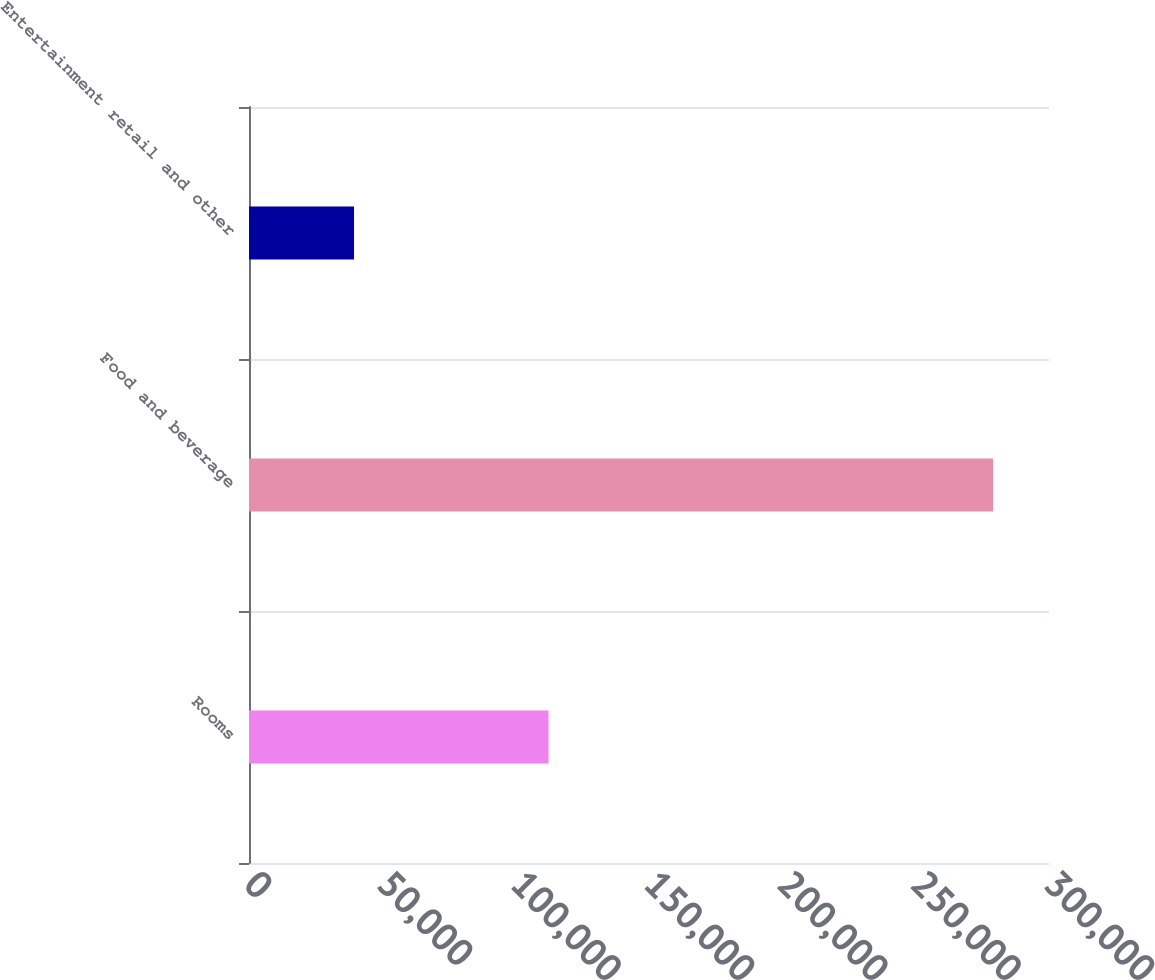<chart> <loc_0><loc_0><loc_500><loc_500><bar_chart><fcel>Rooms<fcel>Food and beverage<fcel>Entertainment retail and other<nl><fcel>112313<fcel>279041<fcel>39388<nl></chart> 